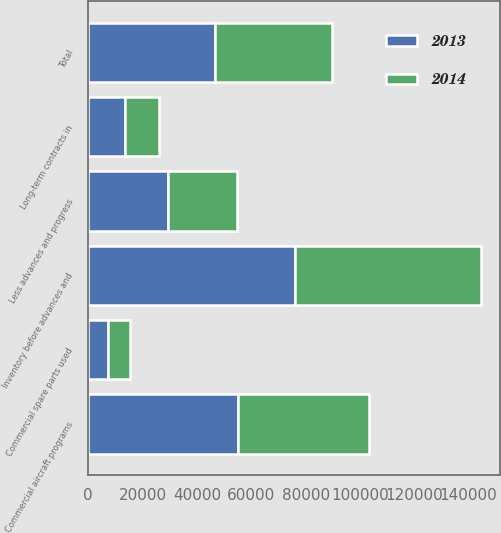<chart> <loc_0><loc_0><loc_500><loc_500><stacked_bar_chart><ecel><fcel>Long-term contracts in<fcel>Commercial aircraft programs<fcel>Commercial spare parts used<fcel>Inventory before advances and<fcel>Less advances and progress<fcel>Total<nl><fcel>2013<fcel>13381<fcel>55220<fcel>7421<fcel>76022<fcel>29266<fcel>46756<nl><fcel>2014<fcel>12608<fcel>48065<fcel>7793<fcel>68466<fcel>25554<fcel>42912<nl></chart> 